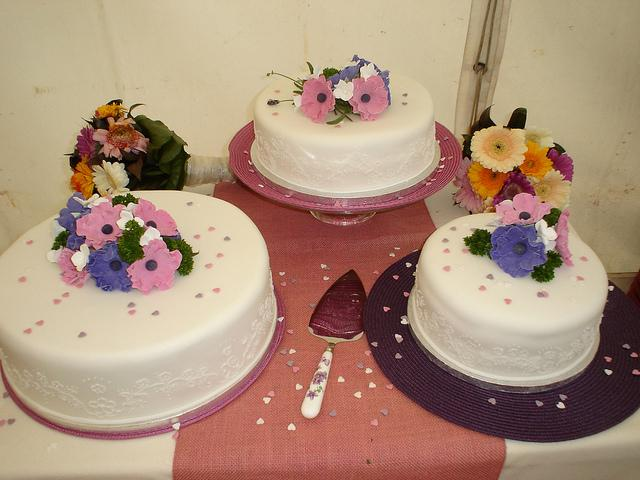What time of icing is on all of the cakes? fondant 